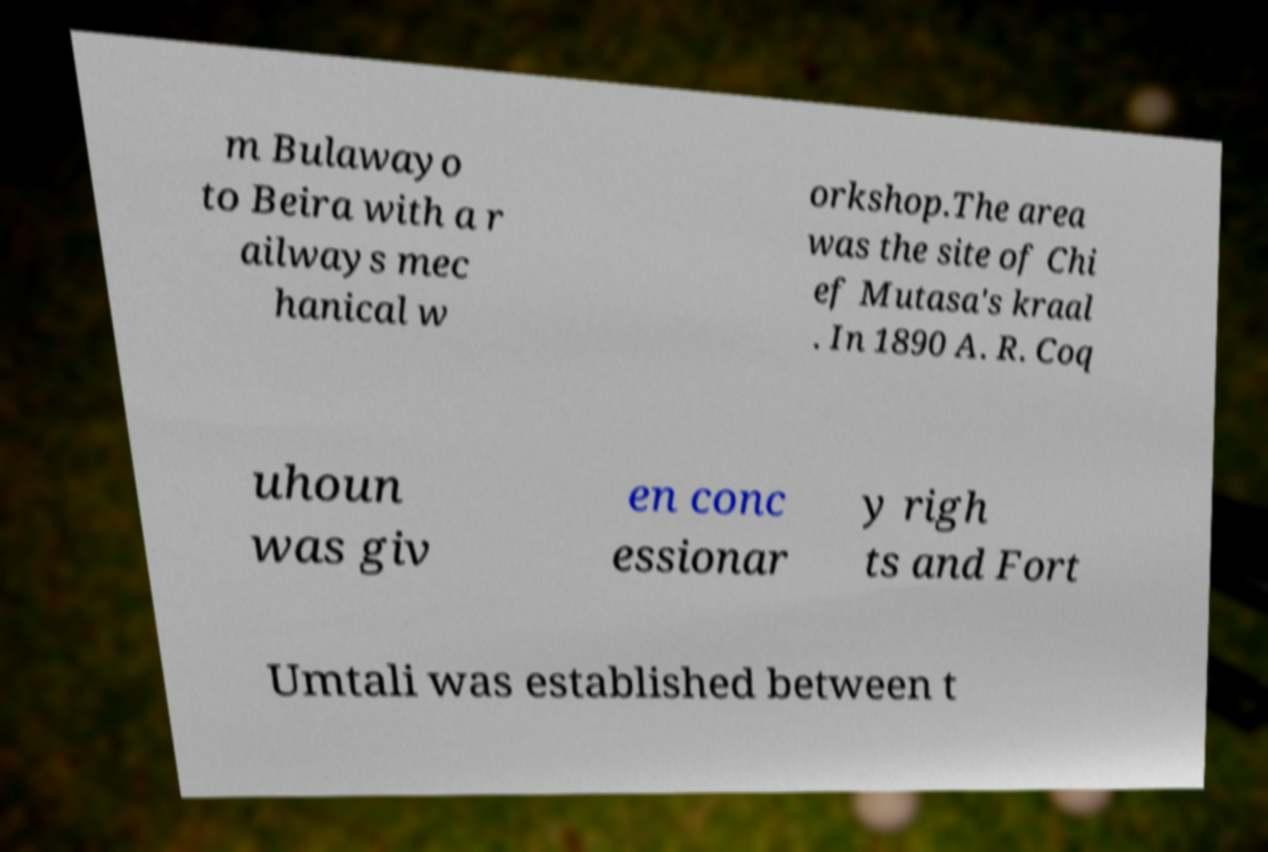Can you read and provide the text displayed in the image?This photo seems to have some interesting text. Can you extract and type it out for me? m Bulawayo to Beira with a r ailways mec hanical w orkshop.The area was the site of Chi ef Mutasa's kraal . In 1890 A. R. Coq uhoun was giv en conc essionar y righ ts and Fort Umtali was established between t 